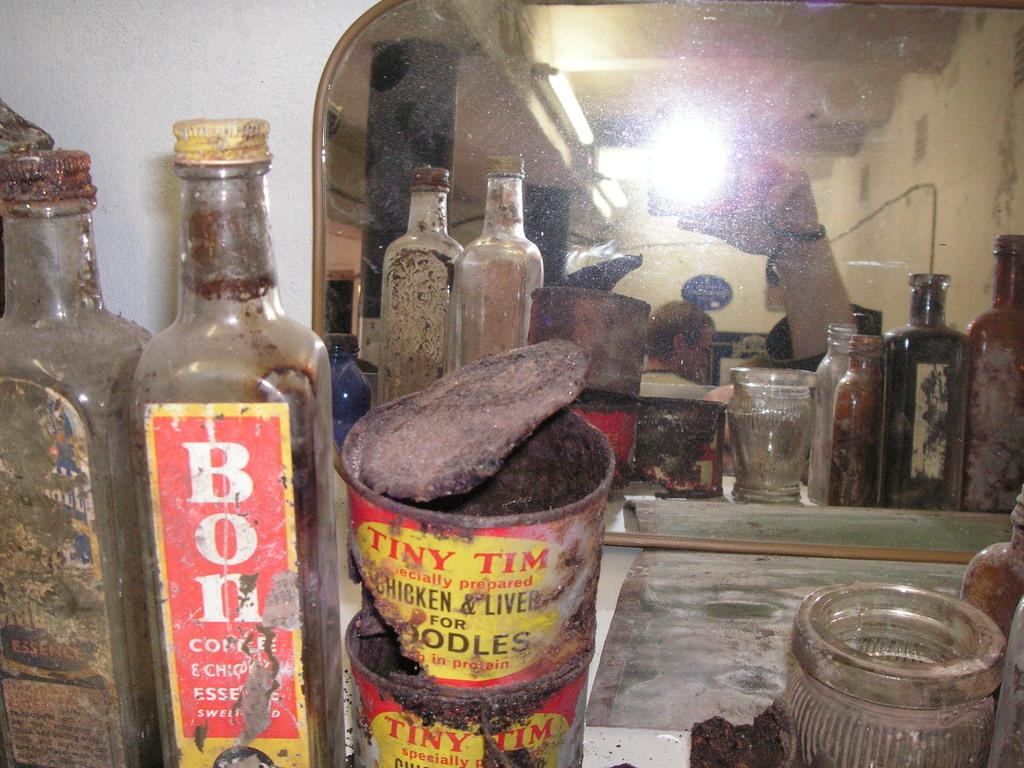<image>
Create a compact narrative representing the image presented. A very old rusty can of noodles is opened and displayed with other old bottles and cans. 